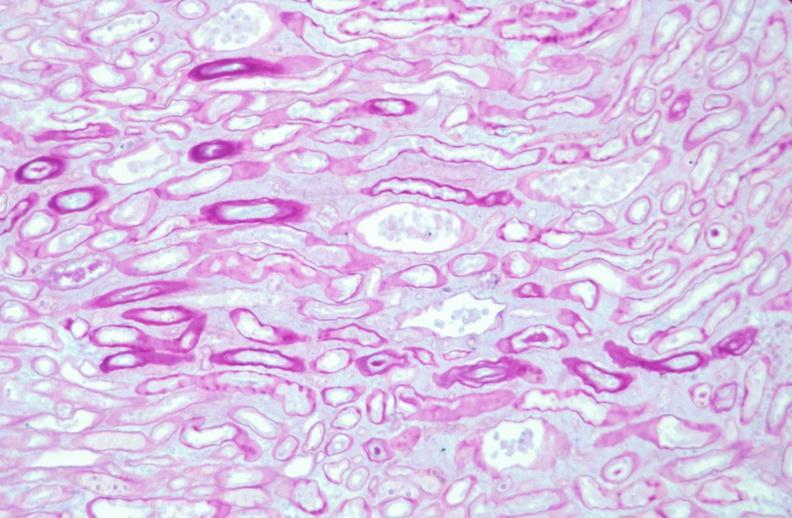why does this image show kidney, thickened and hyalinized basement membranes?
Answer the question using a single word or phrase. Due to diabetes mellitus pas 